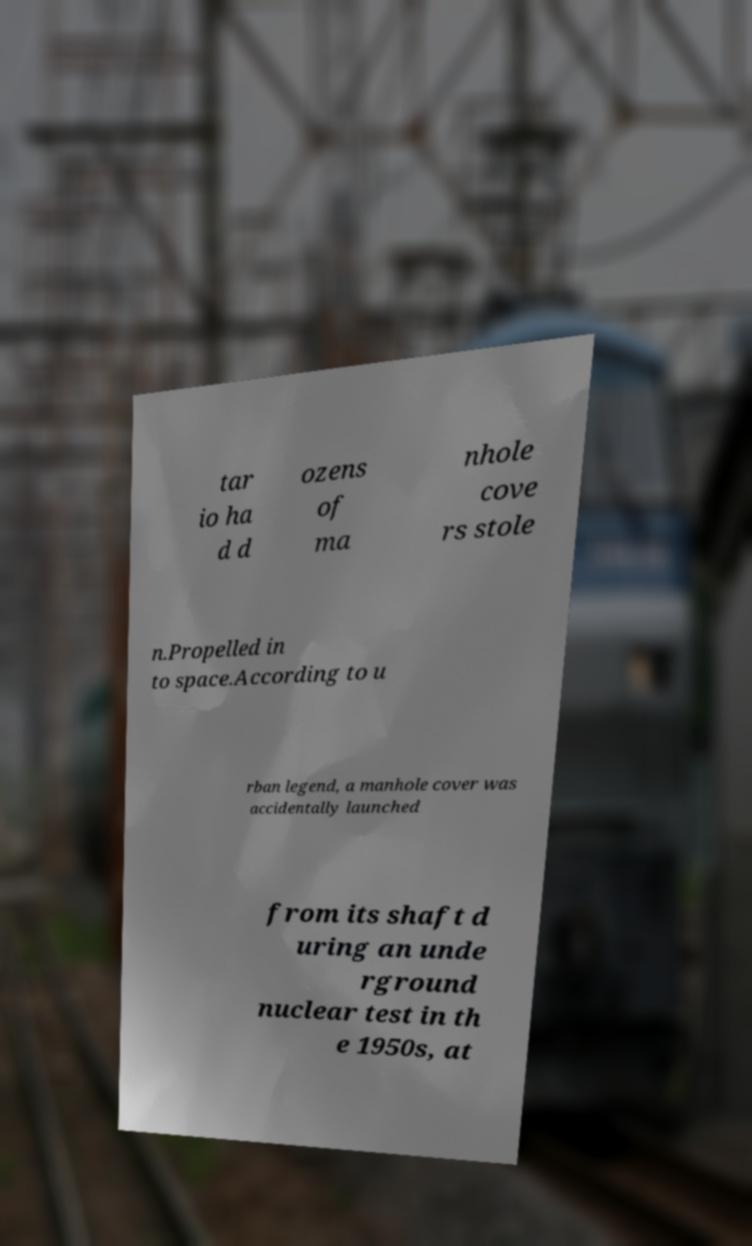Can you accurately transcribe the text from the provided image for me? tar io ha d d ozens of ma nhole cove rs stole n.Propelled in to space.According to u rban legend, a manhole cover was accidentally launched from its shaft d uring an unde rground nuclear test in th e 1950s, at 